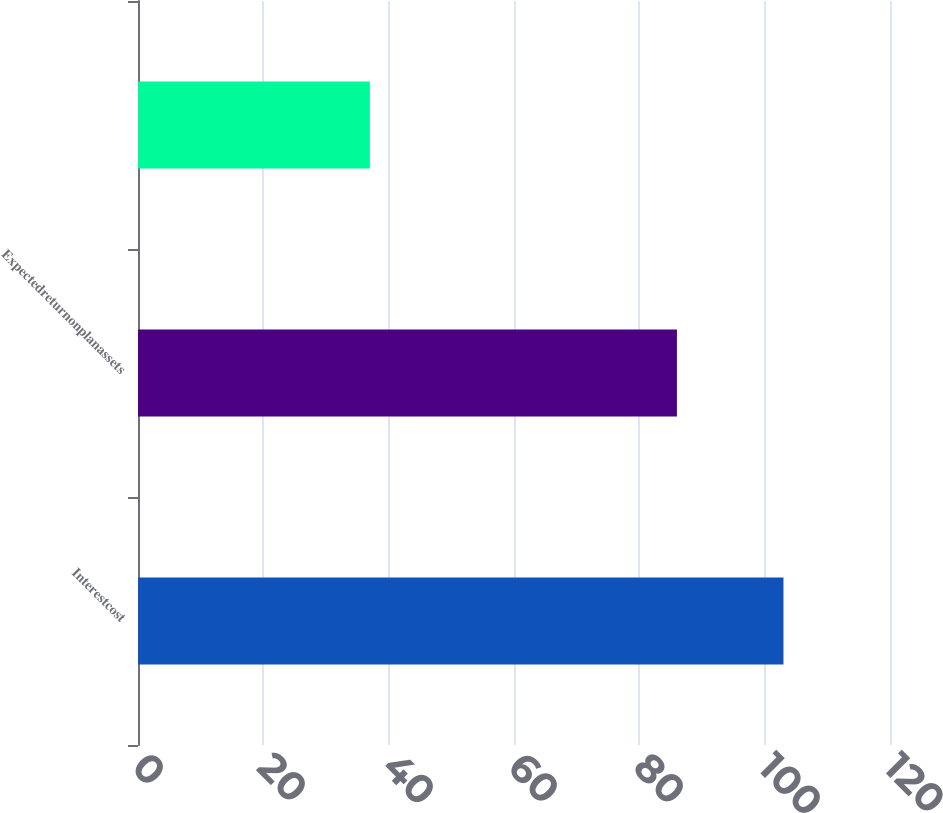<chart> <loc_0><loc_0><loc_500><loc_500><bar_chart><fcel>Interestcost<fcel>Expectedreturnonplanassets<fcel>Unnamed: 2<nl><fcel>103<fcel>86<fcel>37<nl></chart> 